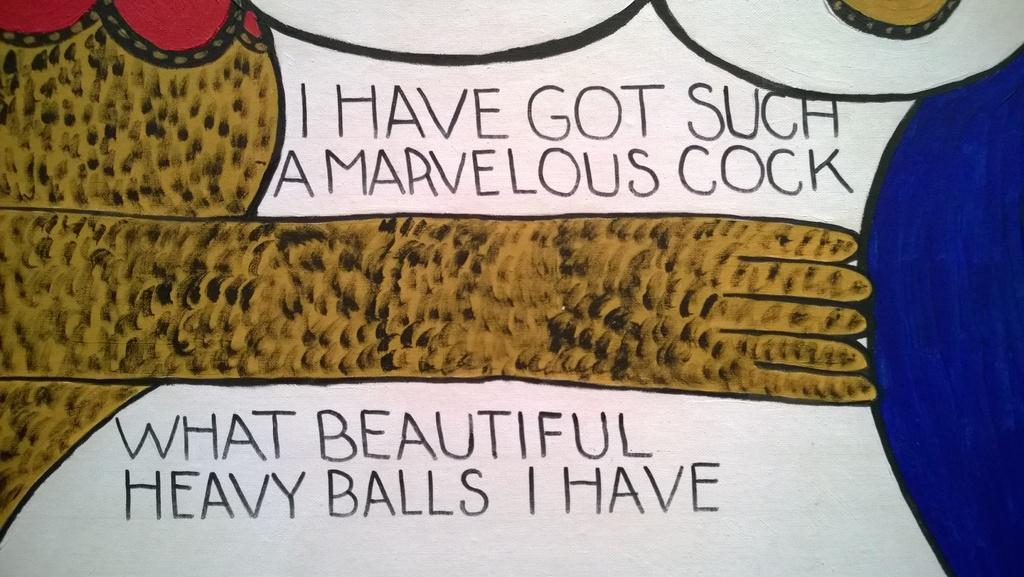How would you summarize this image in a sentence or two? In this image we can see the painting of a hand pushing the ball which is in the blue color. Here we can see the text at the top and bottom as well. 